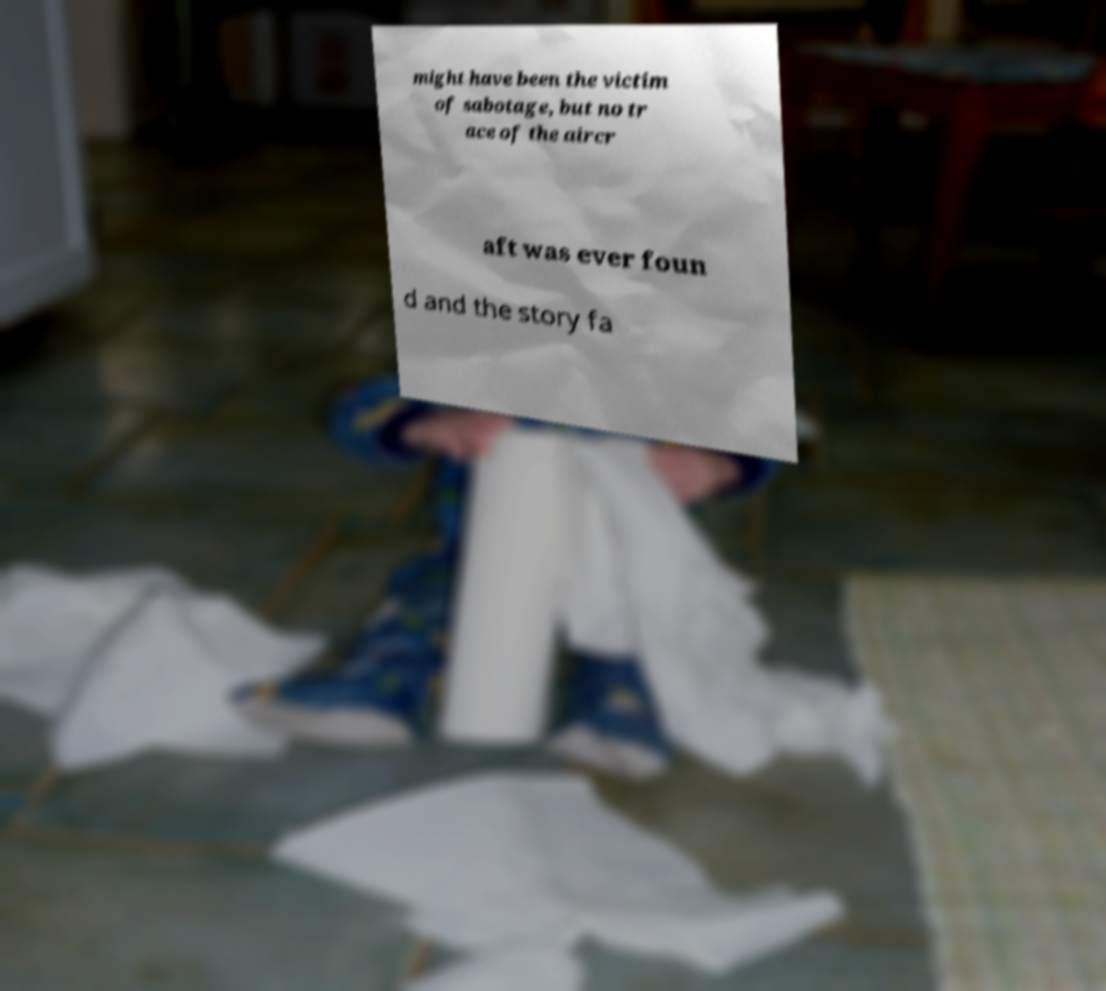For documentation purposes, I need the text within this image transcribed. Could you provide that? might have been the victim of sabotage, but no tr ace of the aircr aft was ever foun d and the story fa 